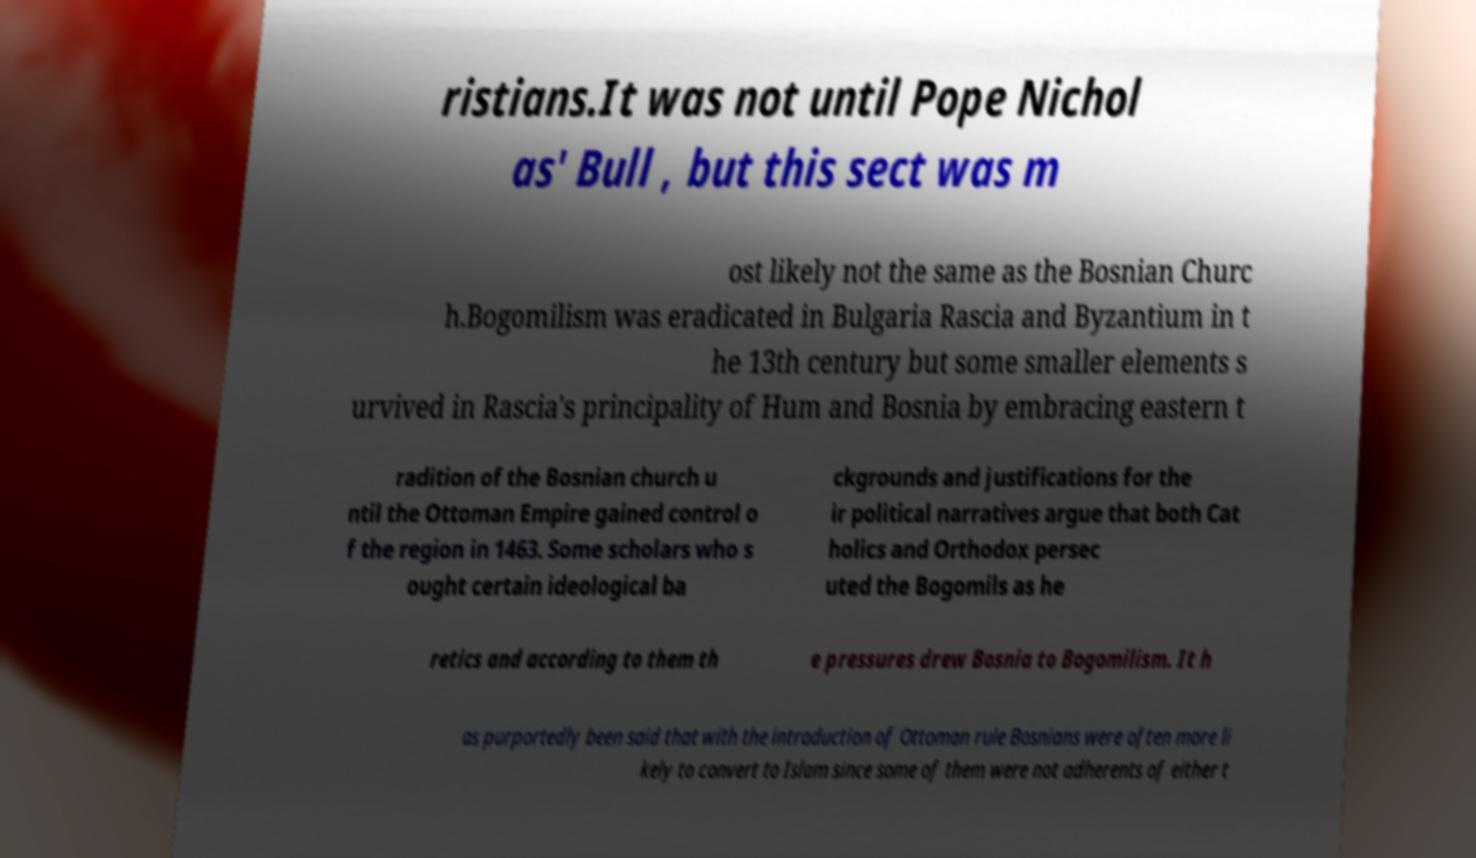What messages or text are displayed in this image? I need them in a readable, typed format. ristians.It was not until Pope Nichol as' Bull , but this sect was m ost likely not the same as the Bosnian Churc h.Bogomilism was eradicated in Bulgaria Rascia and Byzantium in t he 13th century but some smaller elements s urvived in Rascia's principality of Hum and Bosnia by embracing eastern t radition of the Bosnian church u ntil the Ottoman Empire gained control o f the region in 1463. Some scholars who s ought certain ideological ba ckgrounds and justifications for the ir political narratives argue that both Cat holics and Orthodox persec uted the Bogomils as he retics and according to them th e pressures drew Bosnia to Bogomilism. It h as purportedly been said that with the introduction of Ottoman rule Bosnians were often more li kely to convert to Islam since some of them were not adherents of either t 